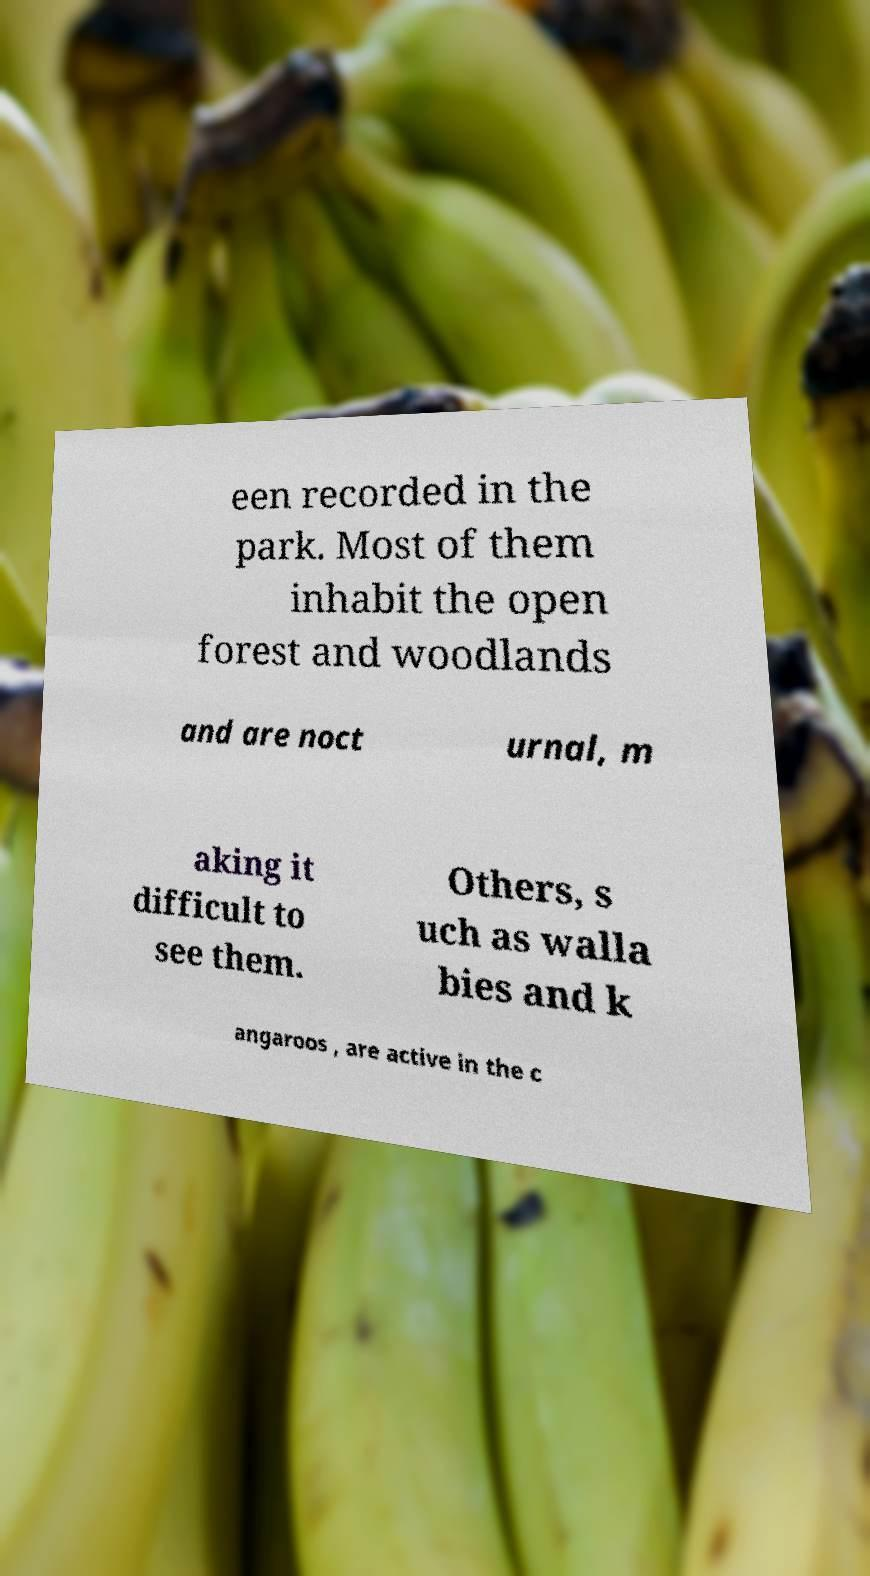There's text embedded in this image that I need extracted. Can you transcribe it verbatim? een recorded in the park. Most of them inhabit the open forest and woodlands and are noct urnal, m aking it difficult to see them. Others, s uch as walla bies and k angaroos , are active in the c 